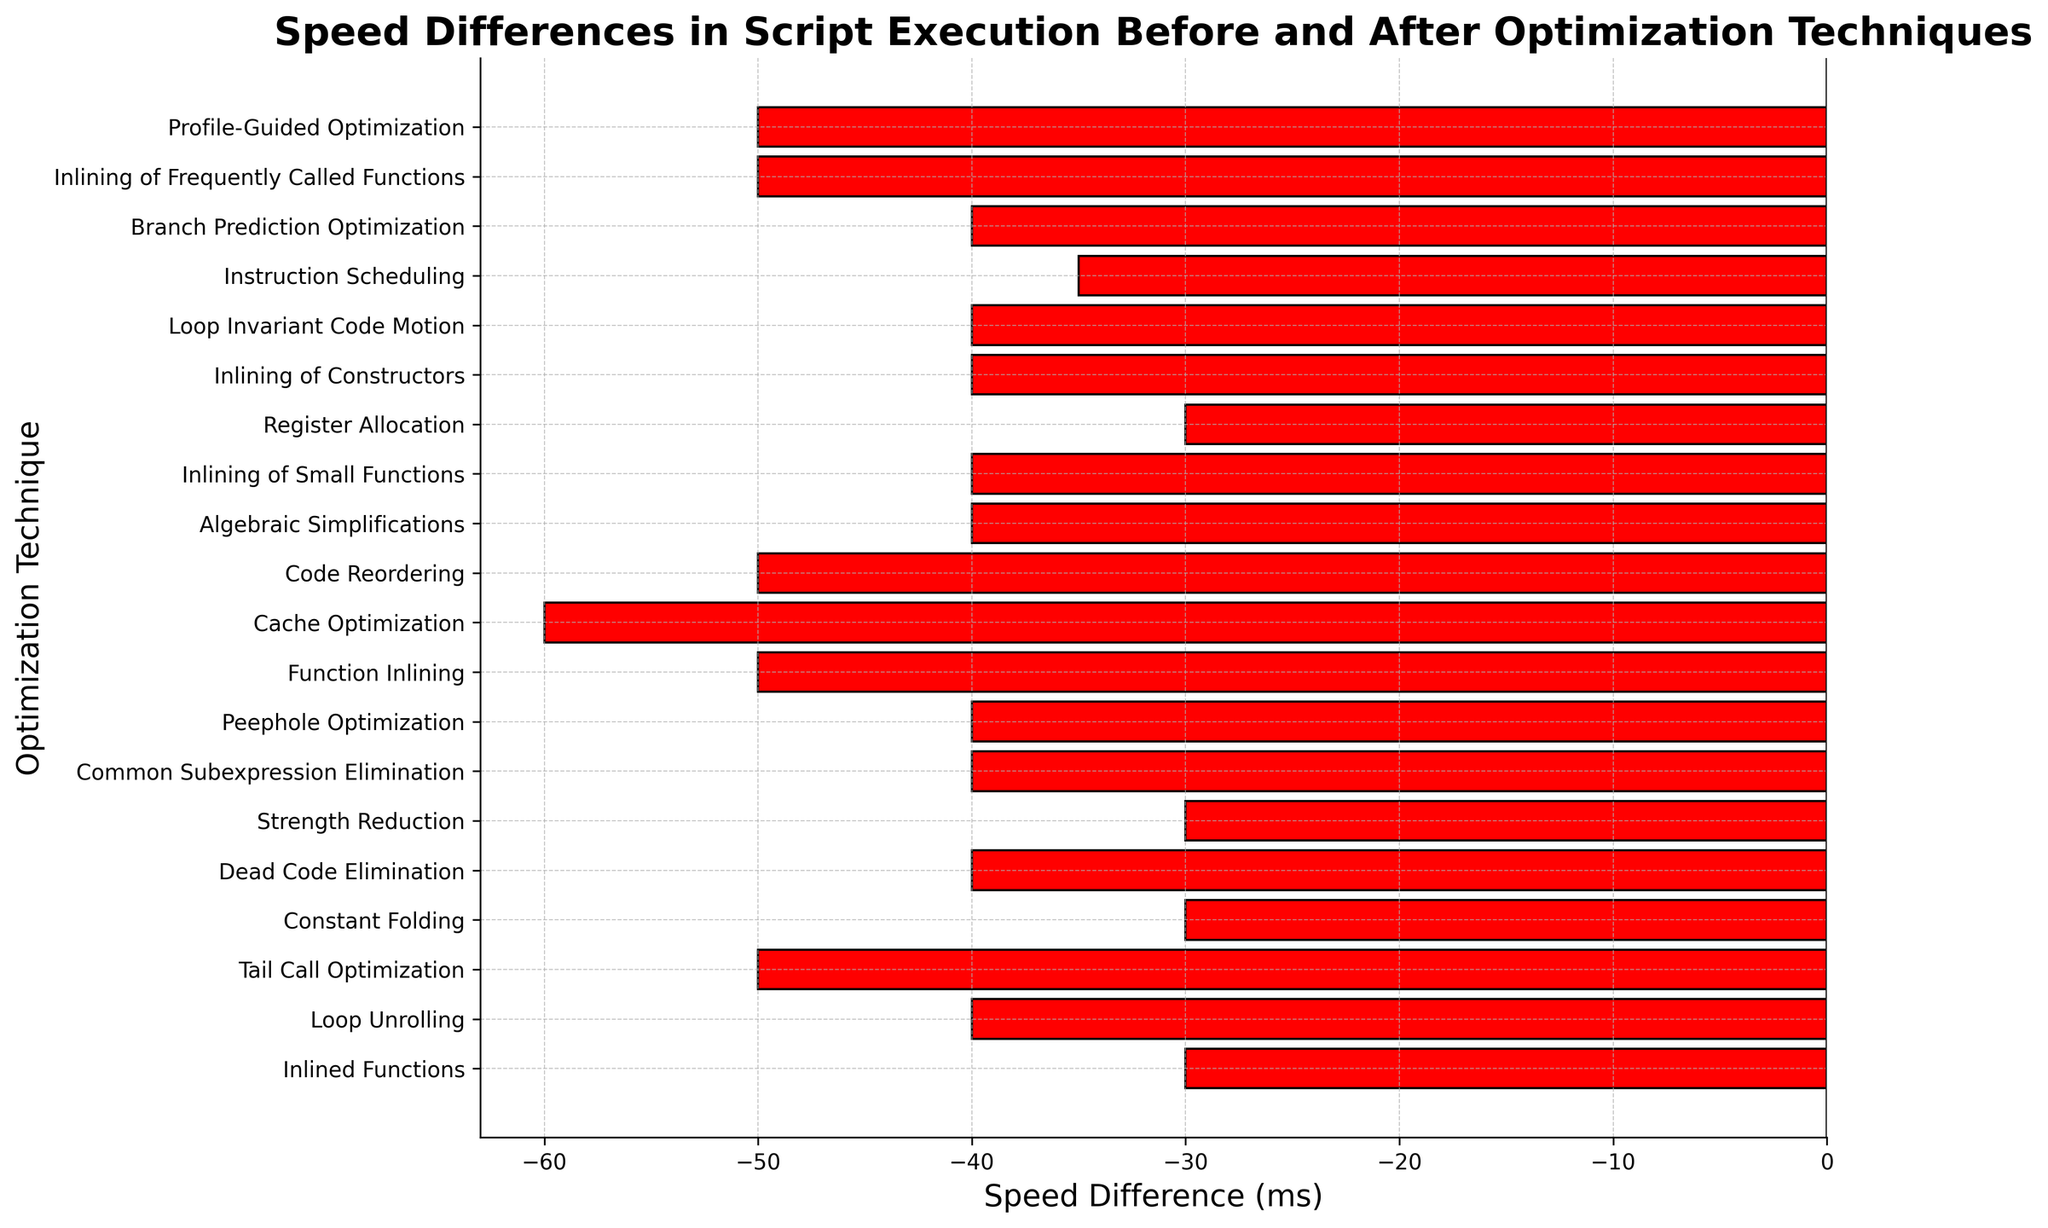What is the maximum speed difference observed and with which technique is it associated? To find the maximum speed difference, look at the bar with the largest magnitude in the negative direction since the values are negative. The longest bar is associated with 'Cache Optimization' with a speed difference of -60 milliseconds.
Answer: -60 ms and Cache Optimization Which technique shows the smallest speed difference in script execution? To find the smallest speed difference, look for the shortest bar among the negative bars. 'Inlined Functions', 'Constant Folding', 'Strength Reduction', and 'Register Allocation' all show a speed difference of -30 milliseconds.
Answer: Inlined Functions, Constant Folding, Strength Reduction, Register Allocation How many techniques have a speed difference of -50 milliseconds? Count the bars that reach -50 on the horizontal axis. The techniques are 'Tail Call Optimization', 'Function Inlining', 'Code Reordering', 'Inlining of Frequently Called Functions', and 'Profile-Guided Optimization', totaling to 5.
Answer: 5 Which technique has the second-largest speed difference after 'Cache Optimization'? 'Cache Optimization' has the largest difference of -60 milliseconds. Find the next longest bars, which belong to 'Tail Call Optimization', 'Function Inlining', 'Code Reordering', 'Inlining of Frequently Called Functions', and 'Profile-Guided Optimization', all showing -50 milliseconds.
Answer: Tail Call Optimization, Function Inlining, Code Reordering, Inlining of Frequently Called Functions, Profile-Guided Optimization Which colors are used in the plot to represent the bars with negative and positive values? The customized bar colors in the plot mark negative speed differences with red and positive speed differences with green. However, in this data, all bars are red indicating all differences are negative.
Answer: Red for negative, Green for positive Sum the speed differences for all techniques involving any form of inlining (Inlined Functions, Function Inlining, Inlining of Small Functions, Inlining of Constructors, Inlining of Frequently Called Functions). Sum the speed differences associated with each inlining technique: -30 (Inlined Functions) + -50 (Function Inlining) + -40 (Inlining of Small Functions) + -40 (Inlining of Constructors) + -50 (Inlining of Frequently Called Functions) = -210 milliseconds.
Answer: -210 ms What is the total number of techniques that have been optimized by exactly -40 milliseconds? Count the bars reaching the -40 mark on the horizontal axis. The techniques are 'Loop Unrolling', 'Dead Code Elimination', 'Common Subexpression Elimination', 'Peephole Optimization', 'Algebraic Simplifications', 'Inlining of Constructors', 'Loop Invariant Code Motion', and 'Branch Prediction Optimization', making a total of 8.
Answer: 8 How does the speed difference for 'Instruction Scheduling' compare with 'Strength Reduction'? Find the bars corresponding to these techniques and compare their lengths. 'Instruction Scheduling' has a speed difference of -35 milliseconds while 'Strength Reduction' has -30 milliseconds. 'Instruction Scheduling' shows a greater reduction.
Answer: Instruction Scheduling has a greater reduction of -35 ms compared to -30 ms for Strength Reduction Which optimization technique shows an improvement closest to the average speed difference of all techniques? Calculate the average speed difference: (-30-40-50-30-40-30-40-40-50-60-50-40-40-30-40-40-35-40-50-50)/20 techniques = -41.5 ms. The closest technique is 'Instruction Scheduling' with -35 milliseconds.
Answer: Instruction Scheduling 